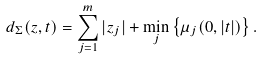Convert formula to latex. <formula><loc_0><loc_0><loc_500><loc_500>d _ { \Sigma } ( z , t ) = \sum _ { j = 1 } ^ { m } | z _ { j } | + \min _ { j } \left \{ \mu _ { j } ( 0 , | t | ) \right \} .</formula> 